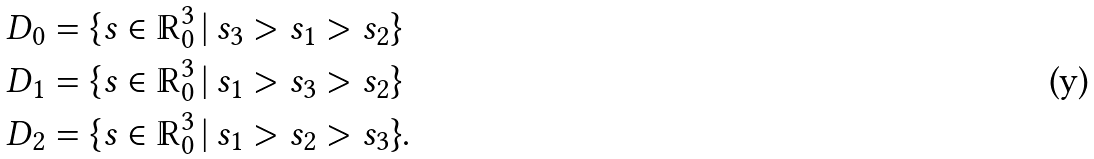<formula> <loc_0><loc_0><loc_500><loc_500>D _ { 0 } & = \{ s \in \mathbb { R } _ { 0 } ^ { 3 } \, | \, s _ { 3 } > s _ { 1 } > s _ { 2 } \} \\ D _ { 1 } & = \{ s \in \mathbb { R } _ { 0 } ^ { 3 } \, | \, s _ { 1 } > s _ { 3 } > s _ { 2 } \} \\ D _ { 2 } & = \{ s \in \mathbb { R } _ { 0 } ^ { 3 } \, | \, s _ { 1 } > s _ { 2 } > s _ { 3 } \} .</formula> 